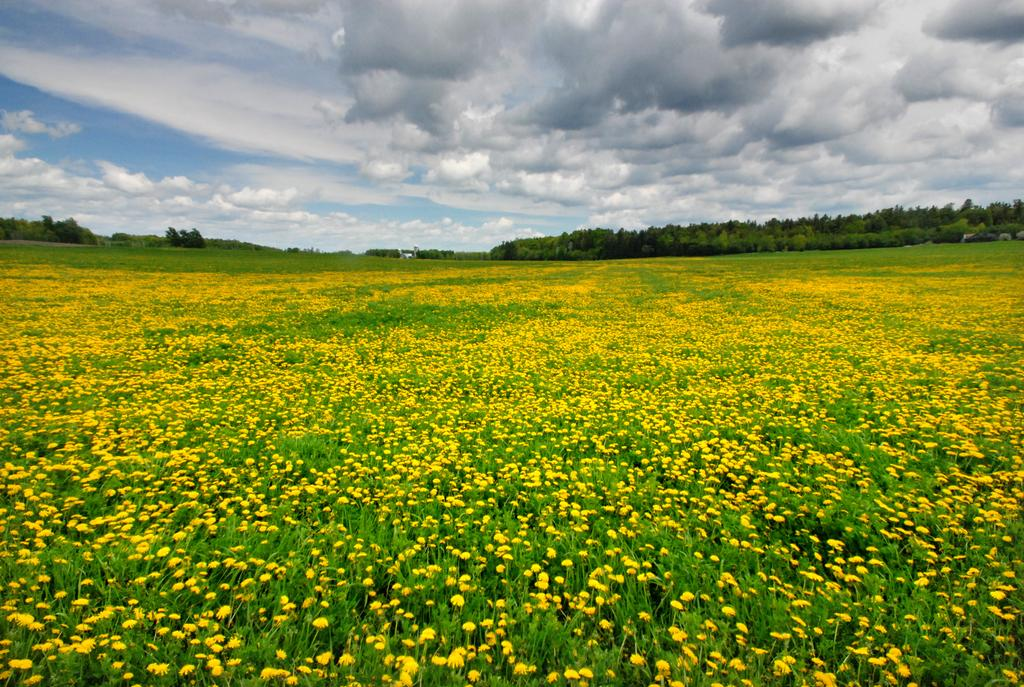What type of plants are present in the image? There are plants with yellow flowers in the image. What can be seen in the background of the image? There are trees and the sky visible in the background of the image. What type of reaction can be seen from the men playing the guitar in the image? There are no men or guitar present in the image; it only features plants with yellow flowers and a background with trees and the sky. 